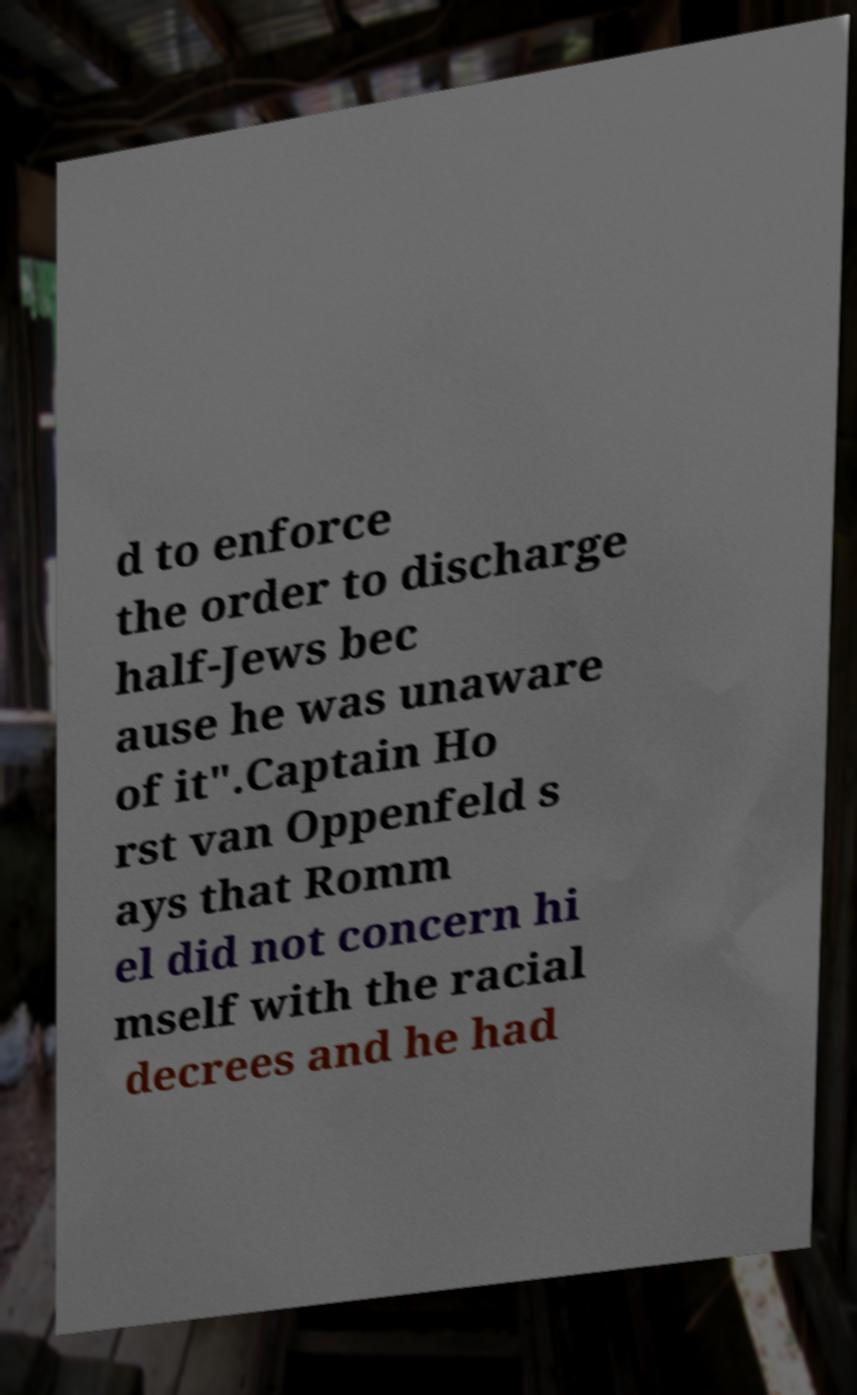There's text embedded in this image that I need extracted. Can you transcribe it verbatim? d to enforce the order to discharge half-Jews bec ause he was unaware of it".Captain Ho rst van Oppenfeld s ays that Romm el did not concern hi mself with the racial decrees and he had 